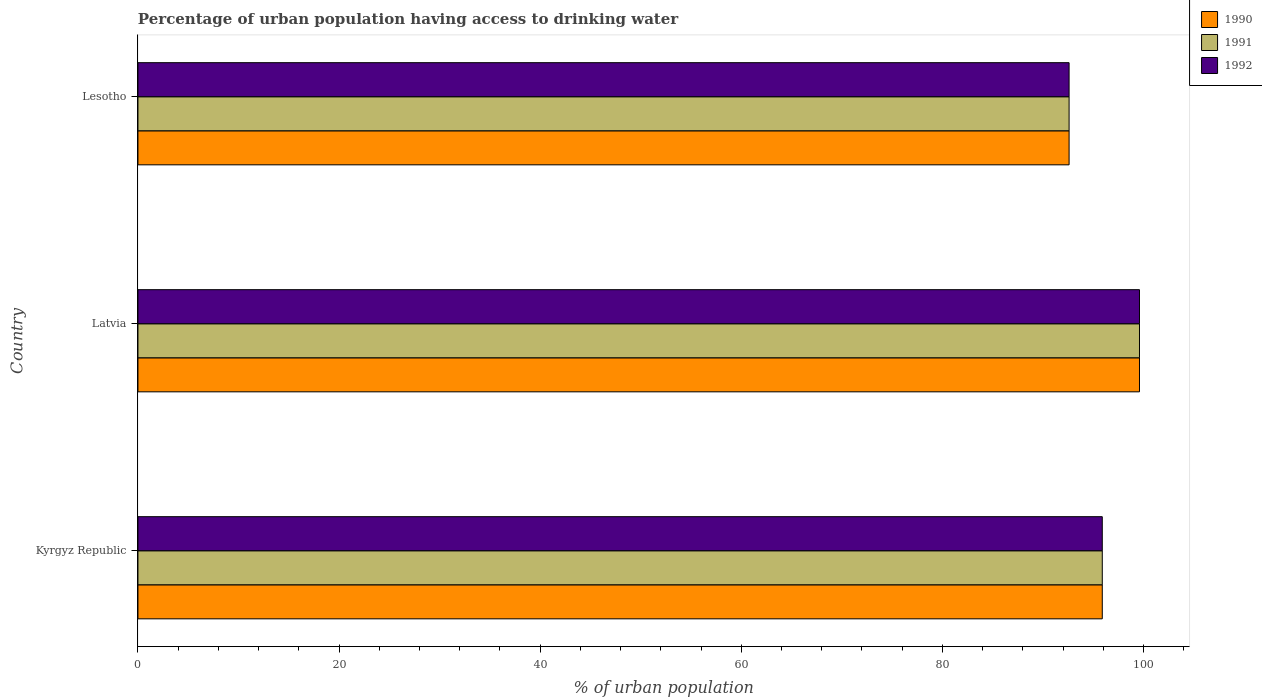How many different coloured bars are there?
Offer a very short reply. 3. How many groups of bars are there?
Offer a terse response. 3. How many bars are there on the 1st tick from the bottom?
Ensure brevity in your answer.  3. What is the label of the 2nd group of bars from the top?
Offer a very short reply. Latvia. In how many cases, is the number of bars for a given country not equal to the number of legend labels?
Provide a short and direct response. 0. What is the percentage of urban population having access to drinking water in 1990 in Kyrgyz Republic?
Your answer should be compact. 95.9. Across all countries, what is the maximum percentage of urban population having access to drinking water in 1990?
Provide a succinct answer. 99.6. Across all countries, what is the minimum percentage of urban population having access to drinking water in 1991?
Offer a very short reply. 92.6. In which country was the percentage of urban population having access to drinking water in 1991 maximum?
Provide a succinct answer. Latvia. In which country was the percentage of urban population having access to drinking water in 1991 minimum?
Give a very brief answer. Lesotho. What is the total percentage of urban population having access to drinking water in 1991 in the graph?
Offer a very short reply. 288.1. What is the difference between the percentage of urban population having access to drinking water in 1990 in Kyrgyz Republic and that in Latvia?
Offer a terse response. -3.7. What is the difference between the percentage of urban population having access to drinking water in 1990 in Lesotho and the percentage of urban population having access to drinking water in 1991 in Kyrgyz Republic?
Offer a terse response. -3.3. What is the average percentage of urban population having access to drinking water in 1992 per country?
Keep it short and to the point. 96.03. What is the difference between the percentage of urban population having access to drinking water in 1990 and percentage of urban population having access to drinking water in 1992 in Latvia?
Offer a terse response. 0. In how many countries, is the percentage of urban population having access to drinking water in 1990 greater than 52 %?
Offer a terse response. 3. What is the ratio of the percentage of urban population having access to drinking water in 1992 in Latvia to that in Lesotho?
Offer a very short reply. 1.08. Is the percentage of urban population having access to drinking water in 1990 in Kyrgyz Republic less than that in Latvia?
Provide a short and direct response. Yes. What is the difference between the highest and the second highest percentage of urban population having access to drinking water in 1992?
Ensure brevity in your answer.  3.7. What is the difference between the highest and the lowest percentage of urban population having access to drinking water in 1991?
Your answer should be very brief. 7. In how many countries, is the percentage of urban population having access to drinking water in 1990 greater than the average percentage of urban population having access to drinking water in 1990 taken over all countries?
Keep it short and to the point. 1. Is the sum of the percentage of urban population having access to drinking water in 1992 in Kyrgyz Republic and Latvia greater than the maximum percentage of urban population having access to drinking water in 1991 across all countries?
Offer a very short reply. Yes. What does the 1st bar from the top in Latvia represents?
Your answer should be very brief. 1992. What does the 1st bar from the bottom in Kyrgyz Republic represents?
Offer a terse response. 1990. How many bars are there?
Your response must be concise. 9. What is the difference between two consecutive major ticks on the X-axis?
Your answer should be very brief. 20. Are the values on the major ticks of X-axis written in scientific E-notation?
Make the answer very short. No. Does the graph contain any zero values?
Your answer should be very brief. No. How many legend labels are there?
Your answer should be very brief. 3. What is the title of the graph?
Make the answer very short. Percentage of urban population having access to drinking water. Does "1985" appear as one of the legend labels in the graph?
Provide a succinct answer. No. What is the label or title of the X-axis?
Give a very brief answer. % of urban population. What is the % of urban population of 1990 in Kyrgyz Republic?
Offer a terse response. 95.9. What is the % of urban population in 1991 in Kyrgyz Republic?
Keep it short and to the point. 95.9. What is the % of urban population of 1992 in Kyrgyz Republic?
Provide a short and direct response. 95.9. What is the % of urban population in 1990 in Latvia?
Give a very brief answer. 99.6. What is the % of urban population in 1991 in Latvia?
Your response must be concise. 99.6. What is the % of urban population of 1992 in Latvia?
Offer a very short reply. 99.6. What is the % of urban population in 1990 in Lesotho?
Offer a very short reply. 92.6. What is the % of urban population of 1991 in Lesotho?
Your answer should be very brief. 92.6. What is the % of urban population of 1992 in Lesotho?
Your answer should be very brief. 92.6. Across all countries, what is the maximum % of urban population in 1990?
Give a very brief answer. 99.6. Across all countries, what is the maximum % of urban population of 1991?
Make the answer very short. 99.6. Across all countries, what is the maximum % of urban population of 1992?
Provide a succinct answer. 99.6. Across all countries, what is the minimum % of urban population in 1990?
Offer a terse response. 92.6. Across all countries, what is the minimum % of urban population in 1991?
Provide a short and direct response. 92.6. Across all countries, what is the minimum % of urban population in 1992?
Provide a succinct answer. 92.6. What is the total % of urban population in 1990 in the graph?
Your response must be concise. 288.1. What is the total % of urban population in 1991 in the graph?
Ensure brevity in your answer.  288.1. What is the total % of urban population of 1992 in the graph?
Offer a terse response. 288.1. What is the difference between the % of urban population in 1990 in Kyrgyz Republic and that in Lesotho?
Offer a very short reply. 3.3. What is the difference between the % of urban population of 1992 in Kyrgyz Republic and that in Lesotho?
Ensure brevity in your answer.  3.3. What is the difference between the % of urban population of 1990 in Latvia and that in Lesotho?
Offer a very short reply. 7. What is the difference between the % of urban population in 1992 in Latvia and that in Lesotho?
Keep it short and to the point. 7. What is the difference between the % of urban population in 1991 in Kyrgyz Republic and the % of urban population in 1992 in Latvia?
Provide a short and direct response. -3.7. What is the difference between the % of urban population of 1990 in Kyrgyz Republic and the % of urban population of 1992 in Lesotho?
Ensure brevity in your answer.  3.3. What is the difference between the % of urban population of 1991 in Kyrgyz Republic and the % of urban population of 1992 in Lesotho?
Your answer should be very brief. 3.3. What is the difference between the % of urban population in 1990 in Latvia and the % of urban population in 1992 in Lesotho?
Provide a succinct answer. 7. What is the difference between the % of urban population in 1991 in Latvia and the % of urban population in 1992 in Lesotho?
Provide a short and direct response. 7. What is the average % of urban population in 1990 per country?
Provide a succinct answer. 96.03. What is the average % of urban population in 1991 per country?
Offer a terse response. 96.03. What is the average % of urban population in 1992 per country?
Your answer should be compact. 96.03. What is the difference between the % of urban population of 1990 and % of urban population of 1991 in Kyrgyz Republic?
Make the answer very short. 0. What is the difference between the % of urban population of 1990 and % of urban population of 1992 in Kyrgyz Republic?
Keep it short and to the point. 0. What is the difference between the % of urban population of 1991 and % of urban population of 1992 in Kyrgyz Republic?
Your response must be concise. 0. What is the difference between the % of urban population in 1991 and % of urban population in 1992 in Latvia?
Make the answer very short. 0. What is the ratio of the % of urban population in 1990 in Kyrgyz Republic to that in Latvia?
Ensure brevity in your answer.  0.96. What is the ratio of the % of urban population in 1991 in Kyrgyz Republic to that in Latvia?
Ensure brevity in your answer.  0.96. What is the ratio of the % of urban population of 1992 in Kyrgyz Republic to that in Latvia?
Keep it short and to the point. 0.96. What is the ratio of the % of urban population of 1990 in Kyrgyz Republic to that in Lesotho?
Provide a succinct answer. 1.04. What is the ratio of the % of urban population in 1991 in Kyrgyz Republic to that in Lesotho?
Keep it short and to the point. 1.04. What is the ratio of the % of urban population of 1992 in Kyrgyz Republic to that in Lesotho?
Your answer should be very brief. 1.04. What is the ratio of the % of urban population of 1990 in Latvia to that in Lesotho?
Give a very brief answer. 1.08. What is the ratio of the % of urban population in 1991 in Latvia to that in Lesotho?
Provide a succinct answer. 1.08. What is the ratio of the % of urban population of 1992 in Latvia to that in Lesotho?
Your response must be concise. 1.08. What is the difference between the highest and the second highest % of urban population in 1991?
Offer a very short reply. 3.7. What is the difference between the highest and the lowest % of urban population of 1990?
Make the answer very short. 7. 